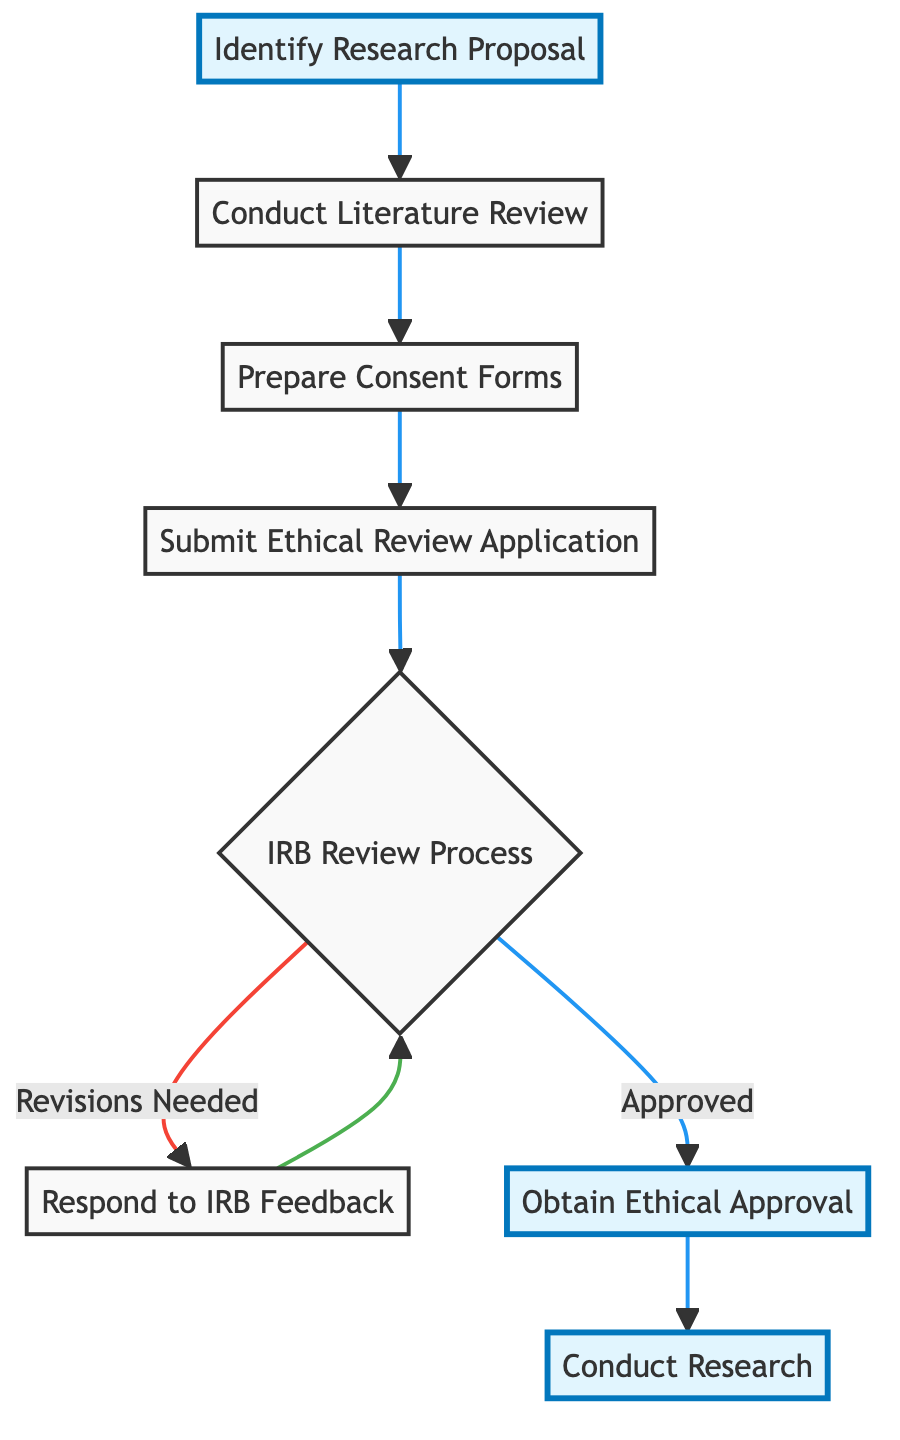What is the first step in the process? The first step in the flow chart is labeled "Identify Research Proposal." This indicates that defining the research objectives and methods is the initial action taken in obtaining ethical approval.
Answer: Identify Research Proposal How many total steps are in the diagram? The flow chart contains a total of 8 steps from the initial research proposal to conducting research, as counted sequentially from start to finish.
Answer: 8 What follows after "Submit Ethical Review Application"? After submitting the application, the next step is "IRB Review Process." This is denoted in the diagram as the immediate subsequent action once the application is submitted.
Answer: IRB Review Process What happens if revisions are needed during the IRB Review Process? If revisions are needed, the flow chart indicates that you must "Respond to IRB Feedback," which is an arrow that loops back to the IRB Review Process until the application is approved.
Answer: Respond to IRB Feedback What is the last step before conducting research? The last step before conducting research is receiving "Obtain Ethical Approval," which is necessary for proceeding with the research as shown in the flow chart.
Answer: Obtain Ethical Approval Which steps feature in the process of preparing for ethical approval? The steps featured in the preparation for ethical approval are "Identify Research Proposal," "Conduct Literature Review," "Prepare Consent Forms," and "Submit Ethical Review Application," listed sequentially at the beginning of the diagram.
Answer: Identifying Research Proposal, Conducting Literature Review, Preparing Consent Forms, Submitting Ethical Review Application What does the diagram indicate happens after obtaining ethical approval? The diagram indicates that once "Obtain Ethical Approval" is complete, the next step is "Conduct Research," which signifies the commencement of the study following approval.
Answer: Conduct Research Which action is highlighted in the flow chart? The steps highlighted in the flow chart are "Identify Research Proposal," "Obtain Ethical Approval," and "Conduct Research," shown with a different color indicating their importance in the process.
Answer: Identify Research Proposal, Obtain Ethical Approval, Conduct Research 